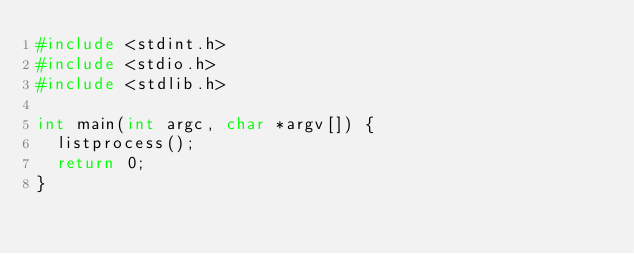Convert code to text. <code><loc_0><loc_0><loc_500><loc_500><_C_>#include <stdint.h>
#include <stdio.h>
#include <stdlib.h>

int main(int argc, char *argv[]) {
	listprocess();
	return 0;
}
</code> 